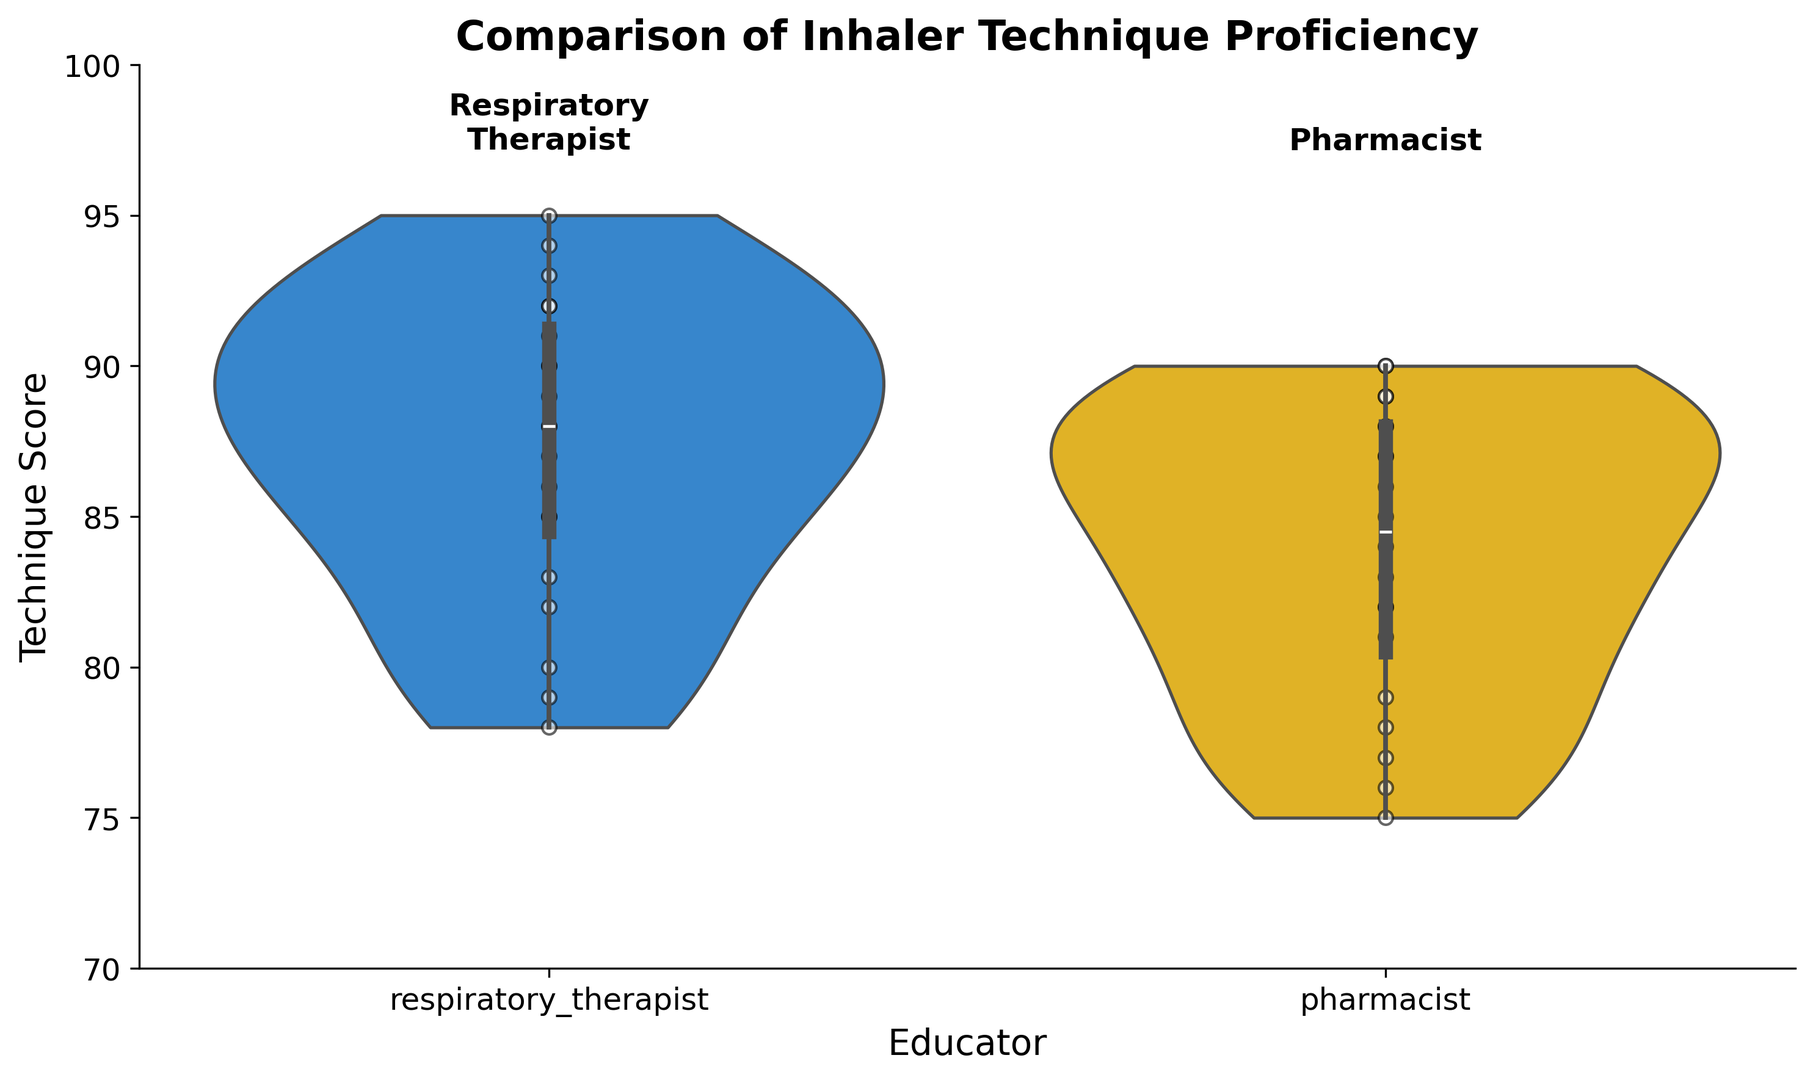Which group has the highest median technique score? To determine the group with the highest median technique score, look at the central horizontal line in each violin plot that represents the median. The median for the respiratory therapists' group is higher than the median for the pharmacists' group.
Answer: Respiratory therapists What range of technique scores is covered by the interquartile range for the pharmacists? The interquartile range (IQR) is represented by the box inside the violin plot, spanning from the 25th percentile to the 75th percentile. For the pharmacists' group, this range approximately covers scores from 78 to 88.
Answer: 78 to 88 How do the distributions of technique scores differ between respiratory therapists and pharmacists? Comparing the shapes and spread of the two violin plots: the respiratory therapists' plot is taller and narrower with more data points concentrated at higher scores, while the pharmacists' plot is wider, indicating more variability. This suggests respiratory therapists achieve higher and more consistent technique scores.
Answer: Respiratory therapists: taller, narrower; Pharmacists: wider, more variable Which educator group has a wider spread in technique scores? To assess the spread, observe the width of the violin plots. The plot for the pharmacists is wider, indicating a larger spread in technique scores.
Answer: Pharmacists What is the approximate highest technique score achieved by any patient in each group? The highest values reached by the violin plots represent the highest technique scores. Both the respiratory therapists and pharmacists groups have maximum scores close to 95.
Answer: Approximately 95 for both groups Do respiratory therapists or pharmacists have more data points (patients) close to the top scores? The scatter points inside the violin plots show individual data points. Respiratory therapists have more data points clustered near the top scores (90s), whereas pharmacists have fewer in that range.
Answer: Respiratory therapists Which group has their lowest technique scores closer to the group's median score? Observing the lower tails of the violin plots, the lowest scores in the respiratory therapists' group are closer to their median compared to the pharmacists' group.
Answer: Respiratory therapists How does the concentration of scores in the upper 80s to mid-90s compare between the two groups? Analyzing the density of the violins, the respiratory therapists' plot is more densely packed in the upper 80s to mid-90s, indicating a higher concentration of patients scoring in that range compared to the pharmacists' plot, which shows a more even distribution across a wider range of scores.
Answer: Higher concentration for respiratory therapists 